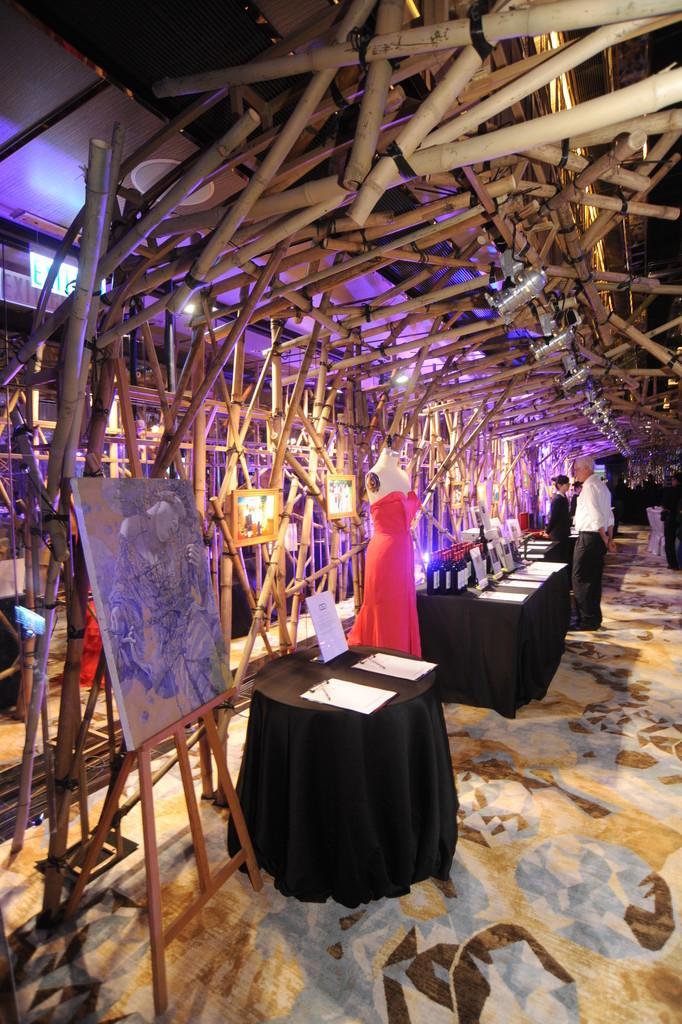Can you describe this image briefly? In the image we can see there is a table on which there are pads in which there are papers kept and there is an artist board on which there are paintings and on the top there are lightings and bamboo sticks are kept. 